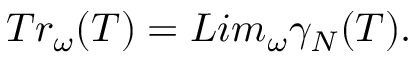Convert formula to latex. <formula><loc_0><loc_0><loc_500><loc_500>T r _ { \omega } ( T ) = L i m _ { \omega } { \gamma } _ { N } ( T ) .</formula> 